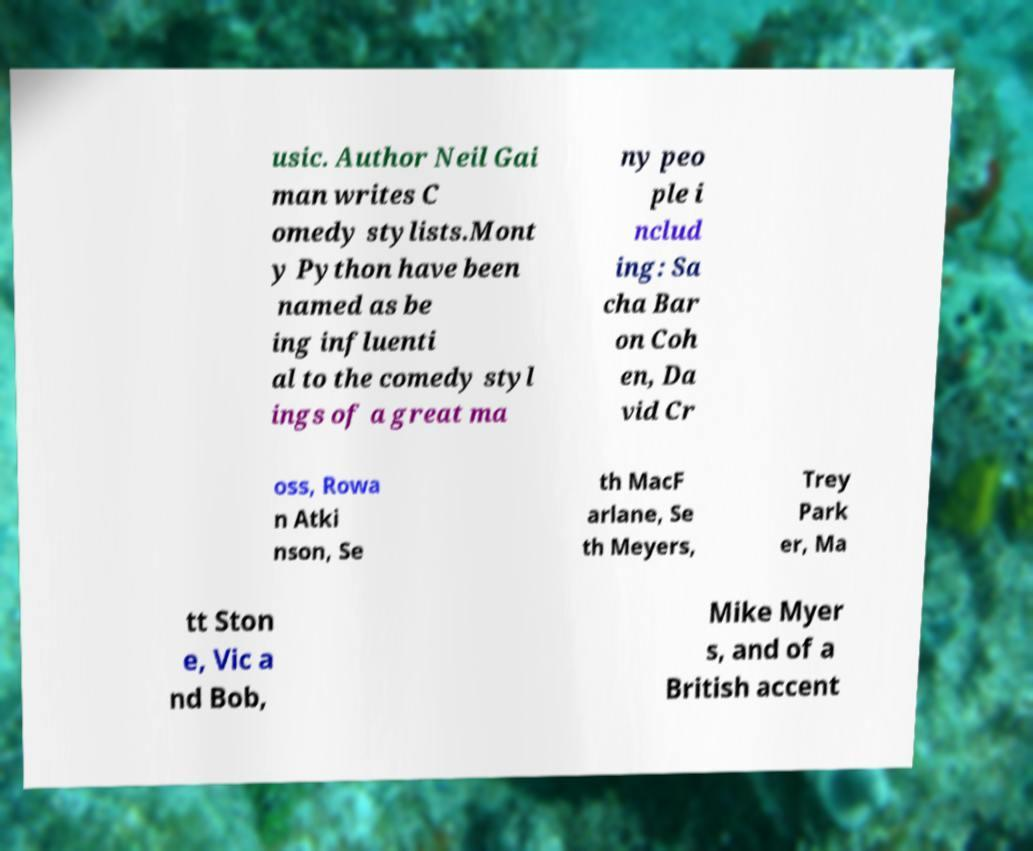What messages or text are displayed in this image? I need them in a readable, typed format. usic. Author Neil Gai man writes C omedy stylists.Mont y Python have been named as be ing influenti al to the comedy styl ings of a great ma ny peo ple i nclud ing: Sa cha Bar on Coh en, Da vid Cr oss, Rowa n Atki nson, Se th MacF arlane, Se th Meyers, Trey Park er, Ma tt Ston e, Vic a nd Bob, Mike Myer s, and of a British accent 